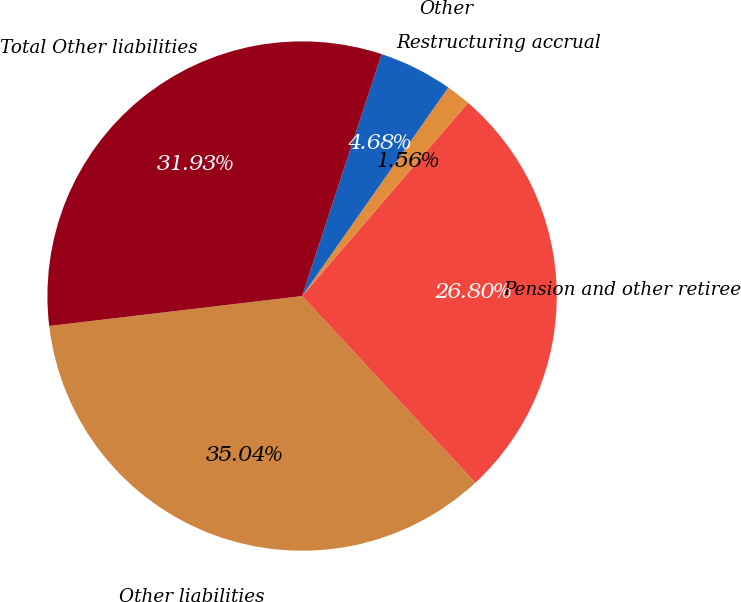Convert chart. <chart><loc_0><loc_0><loc_500><loc_500><pie_chart><fcel>Other liabilities<fcel>Pension and other retiree<fcel>Restructuring accrual<fcel>Other<fcel>Total Other liabilities<nl><fcel>35.04%<fcel>26.8%<fcel>1.56%<fcel>4.68%<fcel>31.93%<nl></chart> 